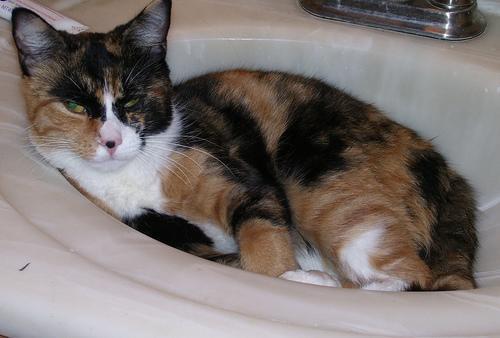How many animals are shown?
Give a very brief answer. 1. How many colors does the cat have?
Give a very brief answer. 3. How many people have remotes in their hands?
Give a very brief answer. 0. 